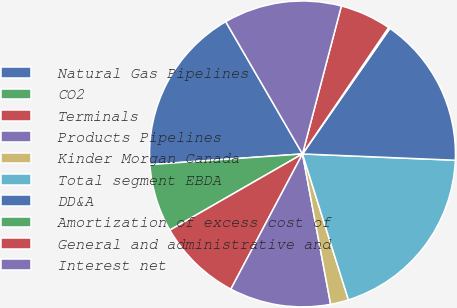<chart> <loc_0><loc_0><loc_500><loc_500><pie_chart><fcel>Natural Gas Pipelines<fcel>CO2<fcel>Terminals<fcel>Products Pipelines<fcel>Kinder Morgan Canada<fcel>Total segment EBDA<fcel>DD&A<fcel>Amortization of excess cost of<fcel>General and administrative and<fcel>Interest net<nl><fcel>17.74%<fcel>7.19%<fcel>8.95%<fcel>10.7%<fcel>1.91%<fcel>19.49%<fcel>15.98%<fcel>0.16%<fcel>5.43%<fcel>12.46%<nl></chart> 